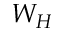<formula> <loc_0><loc_0><loc_500><loc_500>W _ { H }</formula> 